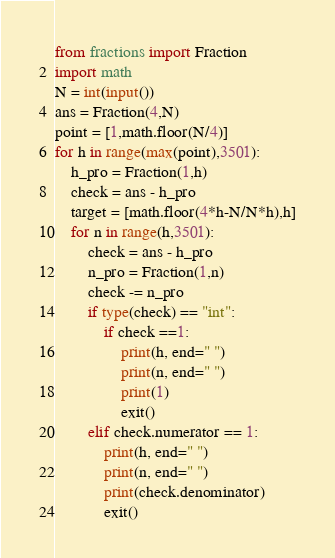Convert code to text. <code><loc_0><loc_0><loc_500><loc_500><_Python_>from fractions import Fraction
import math
N = int(input())
ans = Fraction(4,N)
point = [1,math.floor(N/4)]
for h in range(max(point),3501):
    h_pro = Fraction(1,h)
    check = ans - h_pro
    target = [math.floor(4*h-N/N*h),h]
    for n in range(h,3501):
        check = ans - h_pro
        n_pro = Fraction(1,n)
        check -= n_pro
        if type(check) == "int":
            if check ==1:
                print(h, end=" ")
                print(n, end=" ")
                print(1)
                exit()
        elif check.numerator == 1:
            print(h, end=" ")
            print(n, end=" ")
            print(check.denominator)
            exit()</code> 